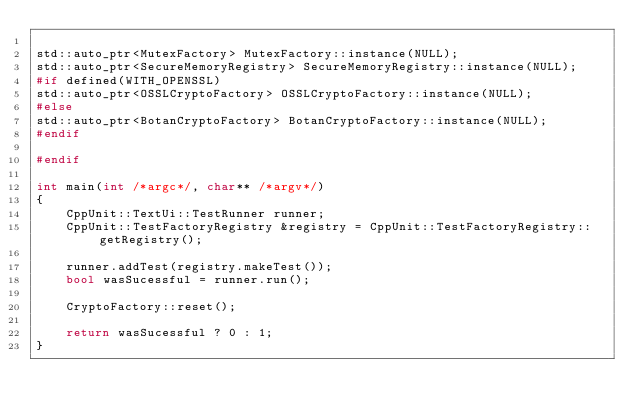<code> <loc_0><loc_0><loc_500><loc_500><_C++_>
std::auto_ptr<MutexFactory> MutexFactory::instance(NULL);
std::auto_ptr<SecureMemoryRegistry> SecureMemoryRegistry::instance(NULL);
#if defined(WITH_OPENSSL)
std::auto_ptr<OSSLCryptoFactory> OSSLCryptoFactory::instance(NULL);
#else
std::auto_ptr<BotanCryptoFactory> BotanCryptoFactory::instance(NULL);
#endif

#endif

int main(int /*argc*/, char** /*argv*/)
{
	CppUnit::TextUi::TestRunner runner;
	CppUnit::TestFactoryRegistry &registry = CppUnit::TestFactoryRegistry::getRegistry();

	runner.addTest(registry.makeTest());
	bool wasSucessful = runner.run();

	CryptoFactory::reset();

	return wasSucessful ? 0 : 1;
}

</code> 